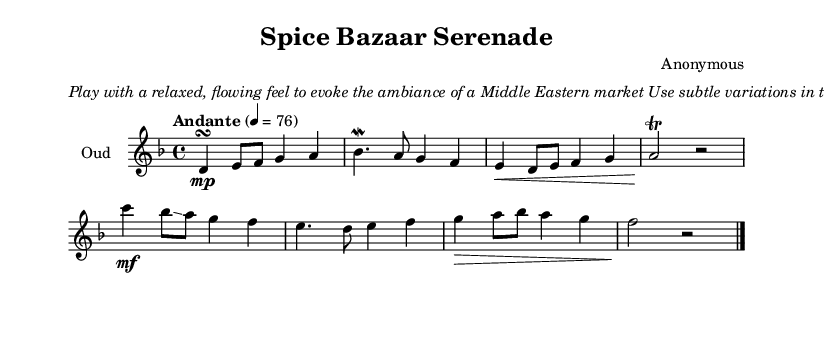What is the key signature of this music? The key signature is indicated by the sharp and flat symbols on the staff. In this case, there are 2 flats, which corresponds to B flat and E flat, indicating the key of D minor.
Answer: D minor What is the time signature of the piece? The time signature is shown at the beginning of the score and indicates how many beats are in a measure. Here, it is shown as 4/4, which means there are 4 beats per measure, and the quarter note gets one beat.
Answer: 4/4 What is the tempo marking for this piece? The tempo marking is located above the staff and guides how fast the music should be played. It states "Andante" followed by a metronome marking of 76, indicating a moderately slow tempo.
Answer: Andante What type of musical ornaments are specified in the score? The score contains specific indications for embellishments, including a turn, mordent, trill, and glissando. Each of these ornaments adds expressiveness characteristic of Middle Eastern music.
Answer: Turn, mordent, trill, glissando Why is emphasizing the ornaments important in this piece? Emphasizing ornaments is crucial in Middle Eastern music as it adds complexity and authenticity to the performance. These embellishments create a sense of improvisation and reflect the style's rich cultural context. The instructions in the markup suggest doing so to evoke the market ambiance.
Answer: Authenticity How many measures does the score contain? To find this, an examination of the score is required. Counting each measure from the beginning to the end shows a total, where every set of vertical lines represents a measure. The count results in a total of 8 measures in the score.
Answer: 8 measures 